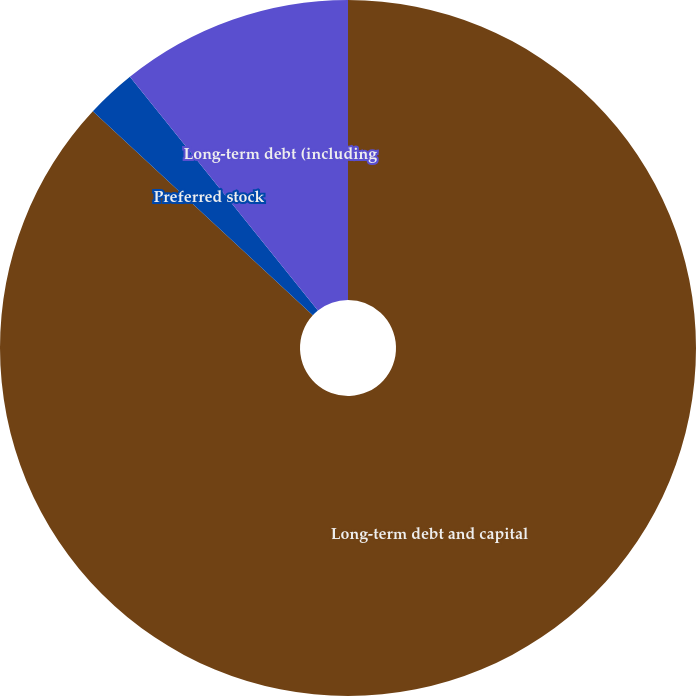Convert chart to OTSL. <chart><loc_0><loc_0><loc_500><loc_500><pie_chart><fcel>Long-term debt and capital<fcel>Preferred stock<fcel>Long-term debt (including<nl><fcel>86.91%<fcel>2.32%<fcel>10.78%<nl></chart> 